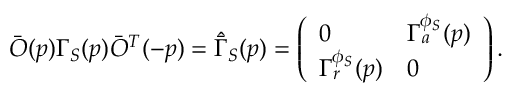<formula> <loc_0><loc_0><loc_500><loc_500>\bar { O } ( p ) \Gamma _ { S } ( p ) \bar { O } ^ { T } ( - p ) = \hat { \bar { \Gamma } } _ { S } ( p ) = \left ( \begin{array} { l l } { 0 } & { { \Gamma _ { a } ^ { \phi _ { S } } ( p ) } } \\ { { \Gamma _ { r } ^ { \phi _ { S } } ( p ) } } & { 0 } \end{array} \right ) .</formula> 